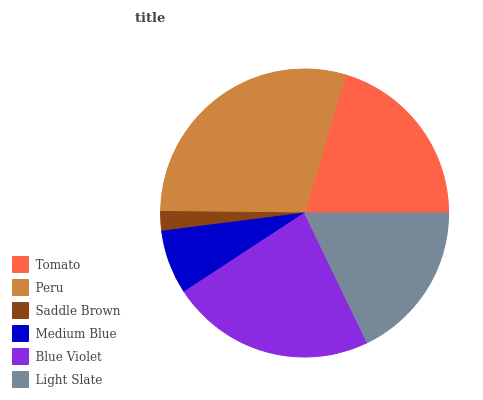Is Saddle Brown the minimum?
Answer yes or no. Yes. Is Peru the maximum?
Answer yes or no. Yes. Is Peru the minimum?
Answer yes or no. No. Is Saddle Brown the maximum?
Answer yes or no. No. Is Peru greater than Saddle Brown?
Answer yes or no. Yes. Is Saddle Brown less than Peru?
Answer yes or no. Yes. Is Saddle Brown greater than Peru?
Answer yes or no. No. Is Peru less than Saddle Brown?
Answer yes or no. No. Is Tomato the high median?
Answer yes or no. Yes. Is Light Slate the low median?
Answer yes or no. Yes. Is Blue Violet the high median?
Answer yes or no. No. Is Saddle Brown the low median?
Answer yes or no. No. 